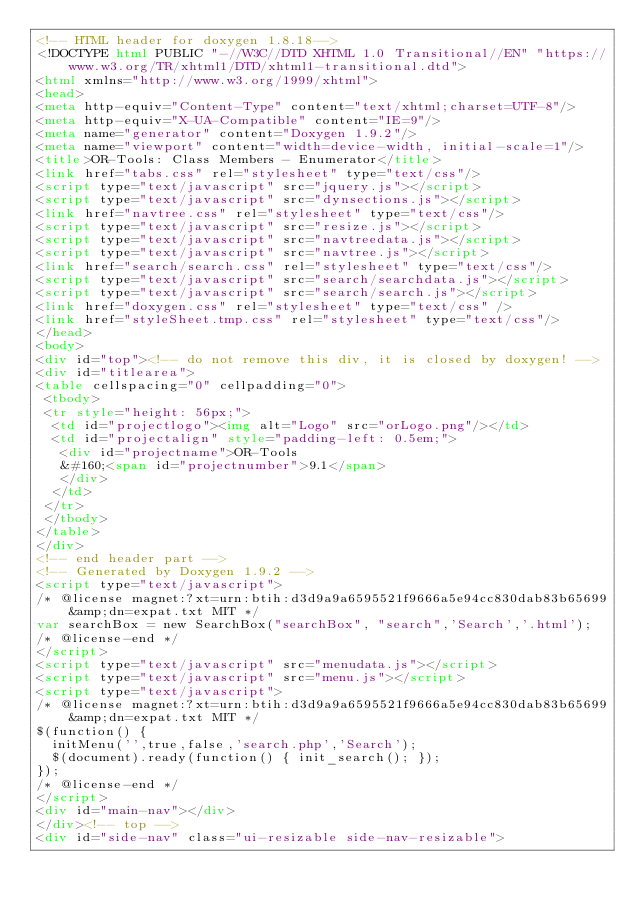<code> <loc_0><loc_0><loc_500><loc_500><_HTML_><!-- HTML header for doxygen 1.8.18-->
<!DOCTYPE html PUBLIC "-//W3C//DTD XHTML 1.0 Transitional//EN" "https://www.w3.org/TR/xhtml1/DTD/xhtml1-transitional.dtd">
<html xmlns="http://www.w3.org/1999/xhtml">
<head>
<meta http-equiv="Content-Type" content="text/xhtml;charset=UTF-8"/>
<meta http-equiv="X-UA-Compatible" content="IE=9"/>
<meta name="generator" content="Doxygen 1.9.2"/>
<meta name="viewport" content="width=device-width, initial-scale=1"/>
<title>OR-Tools: Class Members - Enumerator</title>
<link href="tabs.css" rel="stylesheet" type="text/css"/>
<script type="text/javascript" src="jquery.js"></script>
<script type="text/javascript" src="dynsections.js"></script>
<link href="navtree.css" rel="stylesheet" type="text/css"/>
<script type="text/javascript" src="resize.js"></script>
<script type="text/javascript" src="navtreedata.js"></script>
<script type="text/javascript" src="navtree.js"></script>
<link href="search/search.css" rel="stylesheet" type="text/css"/>
<script type="text/javascript" src="search/searchdata.js"></script>
<script type="text/javascript" src="search/search.js"></script>
<link href="doxygen.css" rel="stylesheet" type="text/css" />
<link href="styleSheet.tmp.css" rel="stylesheet" type="text/css"/>
</head>
<body>
<div id="top"><!-- do not remove this div, it is closed by doxygen! -->
<div id="titlearea">
<table cellspacing="0" cellpadding="0">
 <tbody>
 <tr style="height: 56px;">
  <td id="projectlogo"><img alt="Logo" src="orLogo.png"/></td>
  <td id="projectalign" style="padding-left: 0.5em;">
   <div id="projectname">OR-Tools
   &#160;<span id="projectnumber">9.1</span>
   </div>
  </td>
 </tr>
 </tbody>
</table>
</div>
<!-- end header part -->
<!-- Generated by Doxygen 1.9.2 -->
<script type="text/javascript">
/* @license magnet:?xt=urn:btih:d3d9a9a6595521f9666a5e94cc830dab83b65699&amp;dn=expat.txt MIT */
var searchBox = new SearchBox("searchBox", "search",'Search','.html');
/* @license-end */
</script>
<script type="text/javascript" src="menudata.js"></script>
<script type="text/javascript" src="menu.js"></script>
<script type="text/javascript">
/* @license magnet:?xt=urn:btih:d3d9a9a6595521f9666a5e94cc830dab83b65699&amp;dn=expat.txt MIT */
$(function() {
  initMenu('',true,false,'search.php','Search');
  $(document).ready(function() { init_search(); });
});
/* @license-end */
</script>
<div id="main-nav"></div>
</div><!-- top -->
<div id="side-nav" class="ui-resizable side-nav-resizable"></code> 